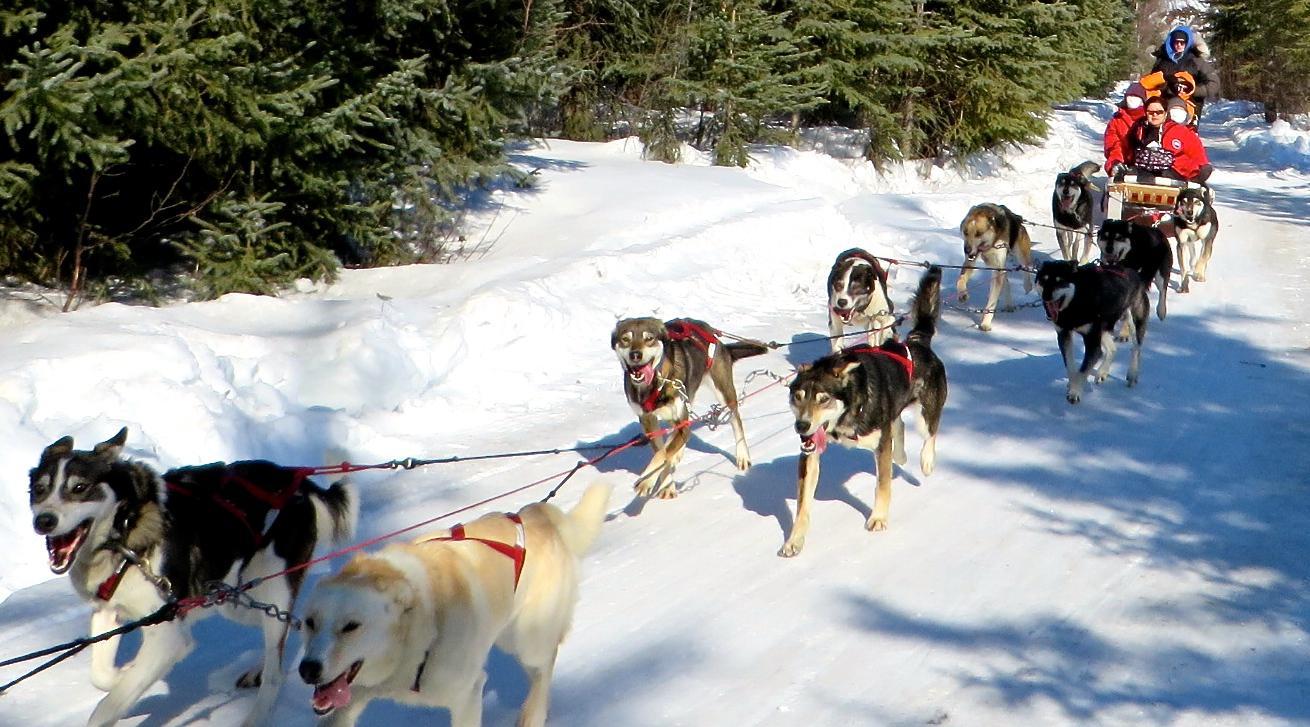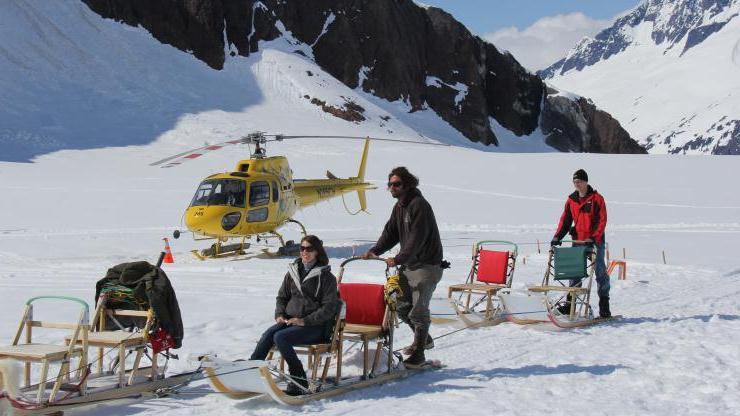The first image is the image on the left, the second image is the image on the right. Considering the images on both sides, is "Three separate teams of sled dogs are harnessed." valid? Answer yes or no. No. The first image is the image on the left, the second image is the image on the right. Examine the images to the left and right. Is the description "An image shows at least one sled but fewer than 3 dogs." accurate? Answer yes or no. Yes. The first image is the image on the left, the second image is the image on the right. Considering the images on both sides, is "There are trees in the image on the left." valid? Answer yes or no. Yes. The first image is the image on the left, the second image is the image on the right. For the images shown, is this caption "No mountains are visible behind the sleds in the right image." true? Answer yes or no. No. 